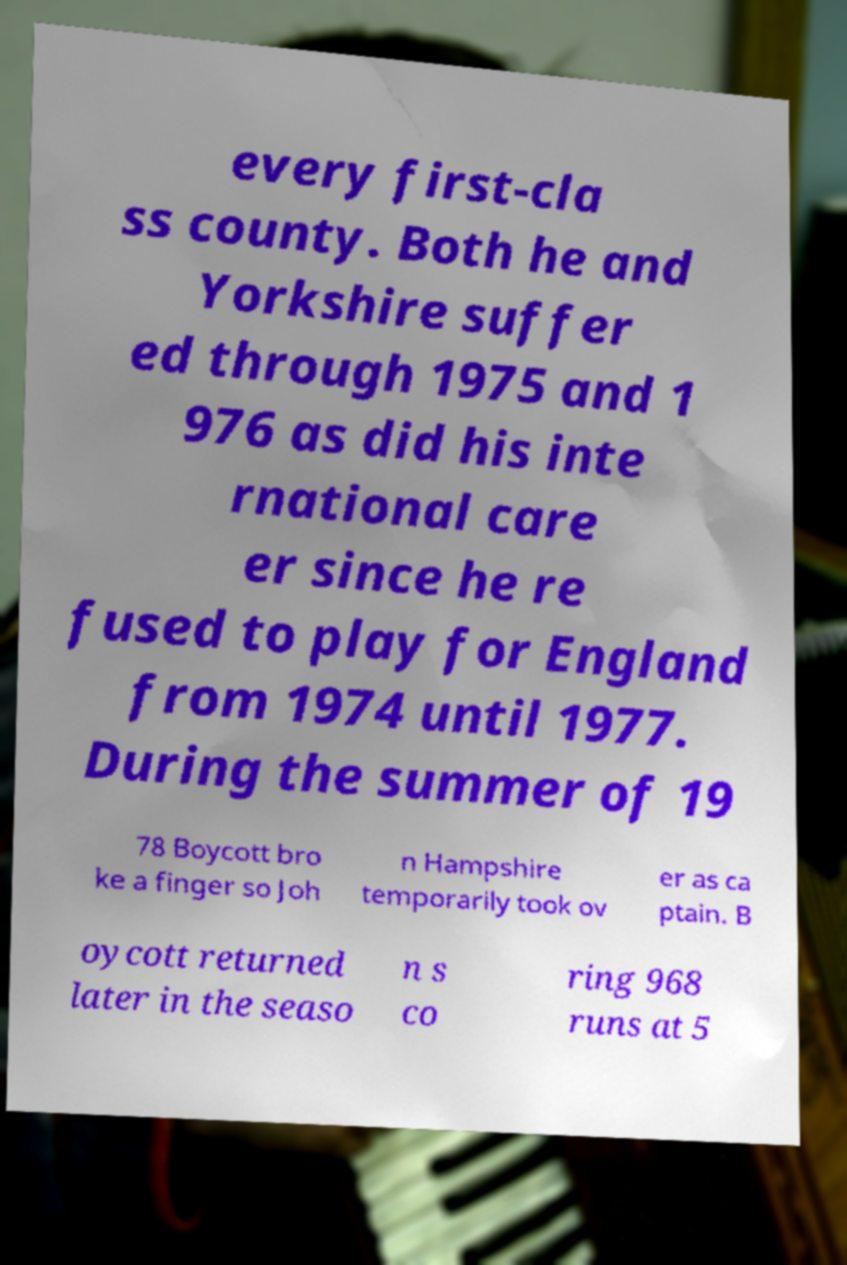Please read and relay the text visible in this image. What does it say? every first-cla ss county. Both he and Yorkshire suffer ed through 1975 and 1 976 as did his inte rnational care er since he re fused to play for England from 1974 until 1977. During the summer of 19 78 Boycott bro ke a finger so Joh n Hampshire temporarily took ov er as ca ptain. B oycott returned later in the seaso n s co ring 968 runs at 5 